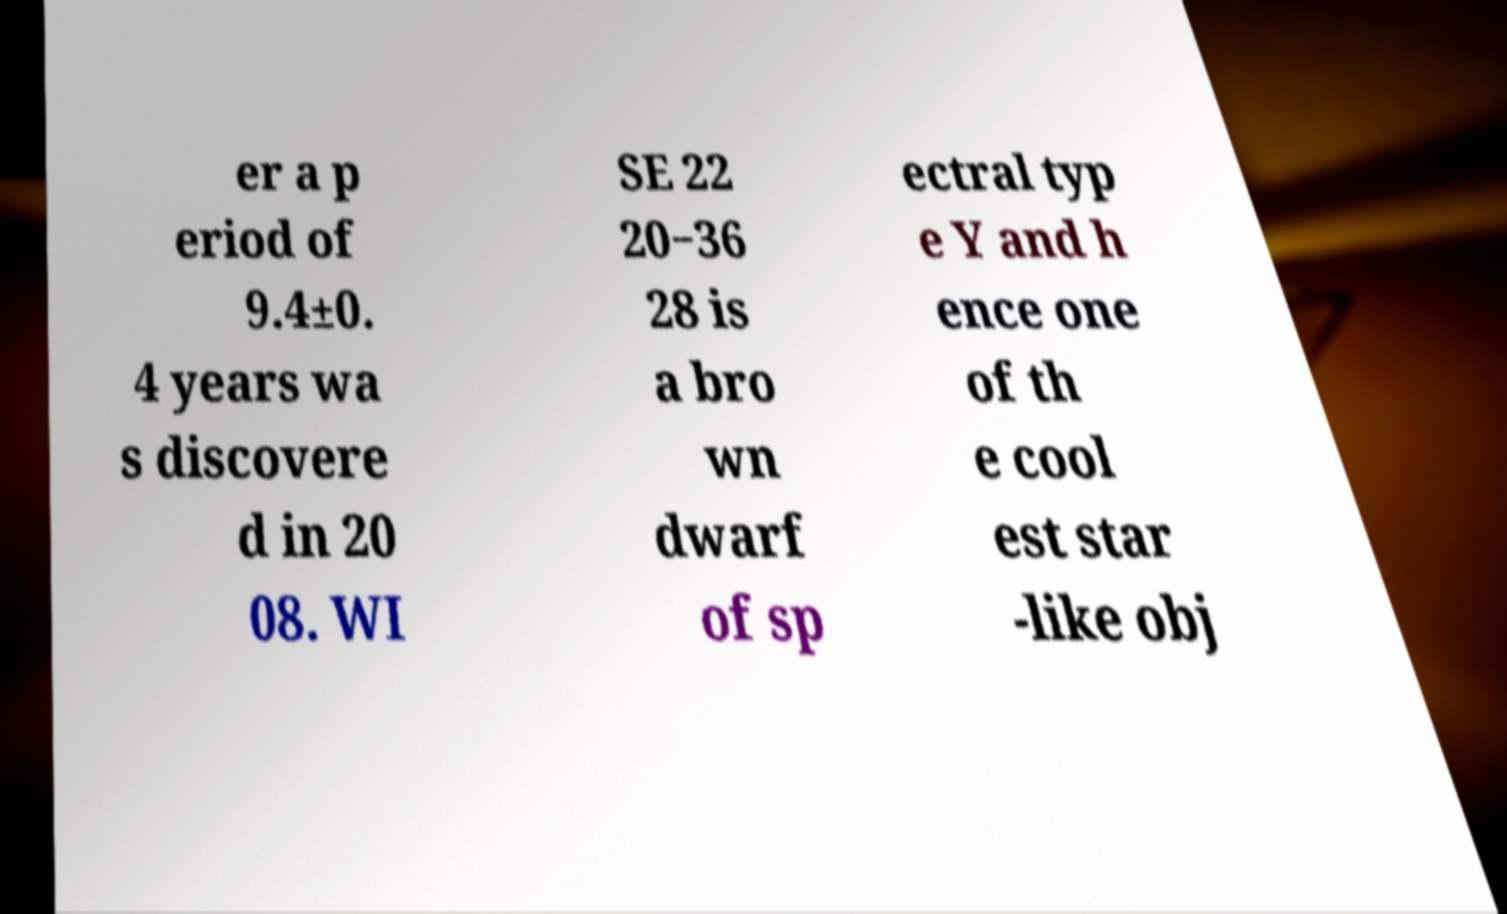There's text embedded in this image that I need extracted. Can you transcribe it verbatim? er a p eriod of 9.4±0. 4 years wa s discovere d in 20 08. WI SE 22 20−36 28 is a bro wn dwarf of sp ectral typ e Y and h ence one of th e cool est star -like obj 